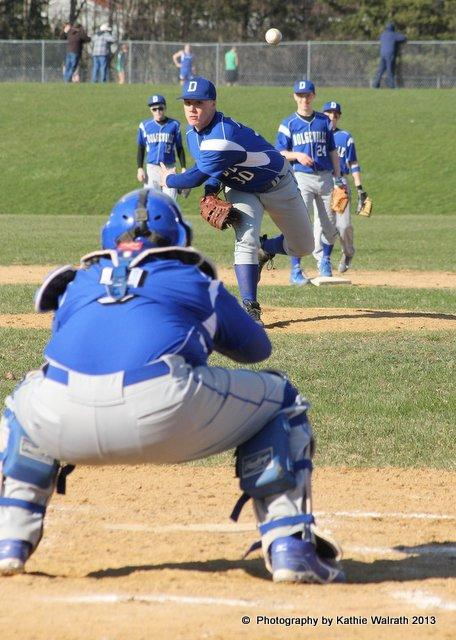What numbered player last touched the ball? Please explain your reasoning. 30. It is clear he just threw the ball. 